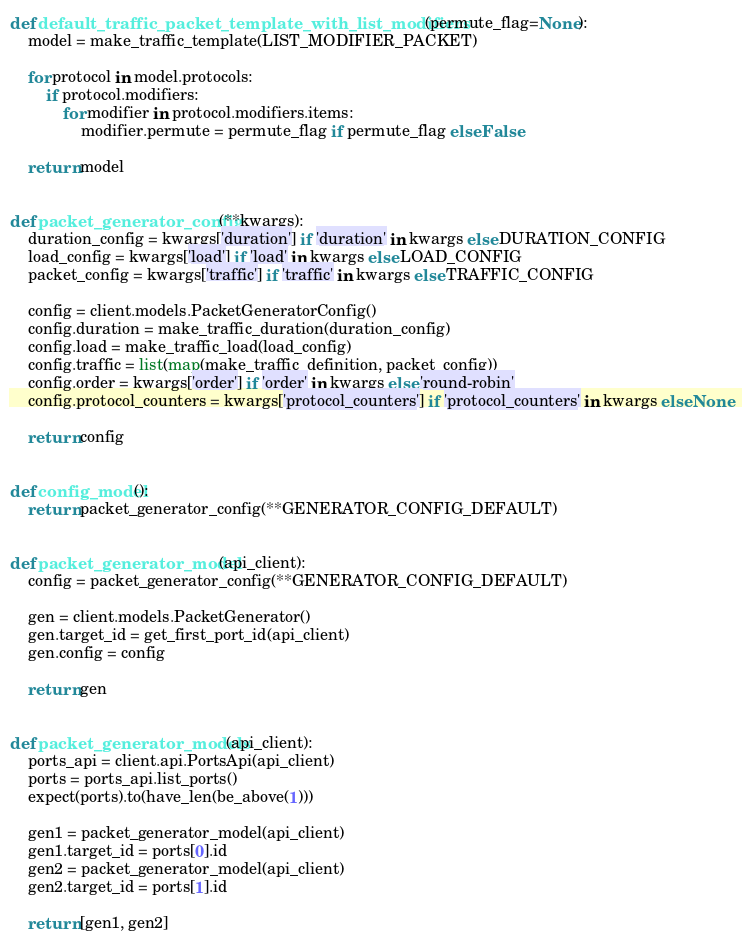<code> <loc_0><loc_0><loc_500><loc_500><_Python_>def default_traffic_packet_template_with_list_modifiers(permute_flag=None):
    model = make_traffic_template(LIST_MODIFIER_PACKET)

    for protocol in model.protocols:
        if protocol.modifiers:
            for modifier in protocol.modifiers.items:
                modifier.permute = permute_flag if permute_flag else False

    return model


def packet_generator_config(**kwargs):
    duration_config = kwargs['duration'] if 'duration' in kwargs else DURATION_CONFIG
    load_config = kwargs['load'] if 'load' in kwargs else LOAD_CONFIG
    packet_config = kwargs['traffic'] if 'traffic' in kwargs else TRAFFIC_CONFIG

    config = client.models.PacketGeneratorConfig()
    config.duration = make_traffic_duration(duration_config)
    config.load = make_traffic_load(load_config)
    config.traffic = list(map(make_traffic_definition, packet_config))
    config.order = kwargs['order'] if 'order' in kwargs else 'round-robin'
    config.protocol_counters = kwargs['protocol_counters'] if 'protocol_counters' in kwargs else None

    return config


def config_model():
    return packet_generator_config(**GENERATOR_CONFIG_DEFAULT)


def packet_generator_model(api_client):
    config = packet_generator_config(**GENERATOR_CONFIG_DEFAULT)

    gen = client.models.PacketGenerator()
    gen.target_id = get_first_port_id(api_client)
    gen.config = config

    return gen


def packet_generator_models(api_client):
    ports_api = client.api.PortsApi(api_client)
    ports = ports_api.list_ports()
    expect(ports).to(have_len(be_above(1)))

    gen1 = packet_generator_model(api_client)
    gen1.target_id = ports[0].id
    gen2 = packet_generator_model(api_client)
    gen2.target_id = ports[1].id

    return [gen1, gen2]
</code> 